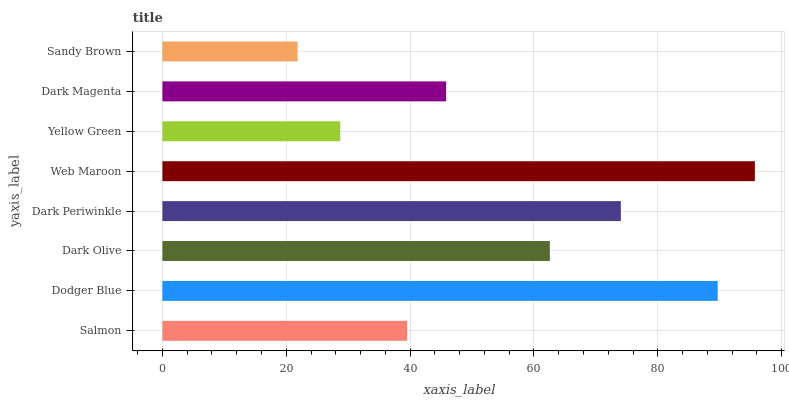Is Sandy Brown the minimum?
Answer yes or no. Yes. Is Web Maroon the maximum?
Answer yes or no. Yes. Is Dodger Blue the minimum?
Answer yes or no. No. Is Dodger Blue the maximum?
Answer yes or no. No. Is Dodger Blue greater than Salmon?
Answer yes or no. Yes. Is Salmon less than Dodger Blue?
Answer yes or no. Yes. Is Salmon greater than Dodger Blue?
Answer yes or no. No. Is Dodger Blue less than Salmon?
Answer yes or no. No. Is Dark Olive the high median?
Answer yes or no. Yes. Is Dark Magenta the low median?
Answer yes or no. Yes. Is Dark Magenta the high median?
Answer yes or no. No. Is Dark Olive the low median?
Answer yes or no. No. 